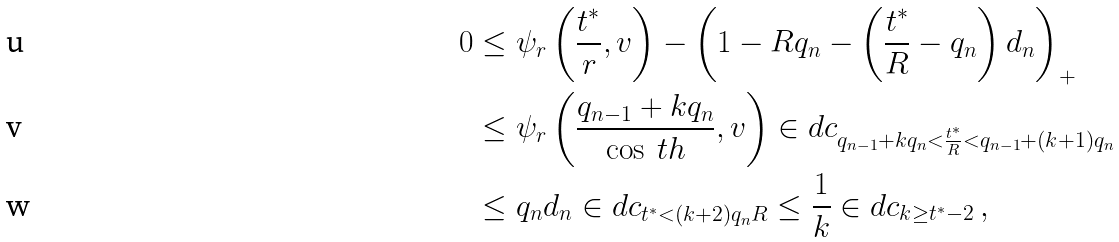<formula> <loc_0><loc_0><loc_500><loc_500>0 & \leq \psi _ { r } \left ( \frac { t ^ { * } } { r } , v \right ) - \left ( 1 - R q _ { n } - \left ( \frac { t ^ { * } } { R } - q _ { n } \right ) d _ { n } \right ) _ { + } \\ & \leq \psi _ { r } \left ( \frac { q _ { n - 1 } + k q _ { n } } { \cos \ t h } , v \right ) \in d c _ { q _ { n - 1 } + k q _ { n } < \frac { t ^ { * } } { R } < q _ { n - 1 } + ( k + 1 ) q _ { n } } \\ & \leq q _ { n } d _ { n } \in d c _ { t ^ { * } < ( k + 2 ) q _ { n } R } \leq \frac { 1 } { k } \in d c _ { k \geq t ^ { * } - 2 } \, ,</formula> 